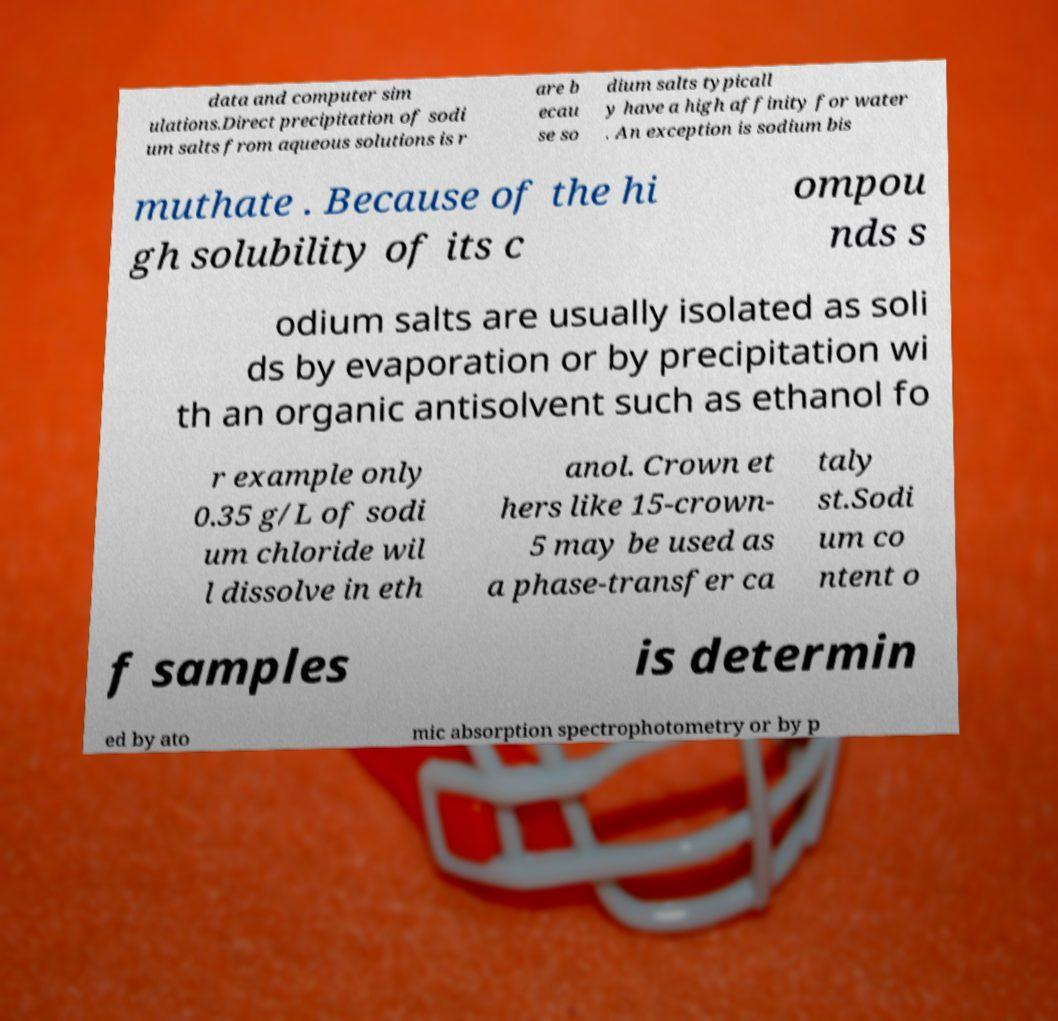There's text embedded in this image that I need extracted. Can you transcribe it verbatim? data and computer sim ulations.Direct precipitation of sodi um salts from aqueous solutions is r are b ecau se so dium salts typicall y have a high affinity for water . An exception is sodium bis muthate . Because of the hi gh solubility of its c ompou nds s odium salts are usually isolated as soli ds by evaporation or by precipitation wi th an organic antisolvent such as ethanol fo r example only 0.35 g/L of sodi um chloride wil l dissolve in eth anol. Crown et hers like 15-crown- 5 may be used as a phase-transfer ca taly st.Sodi um co ntent o f samples is determin ed by ato mic absorption spectrophotometry or by p 